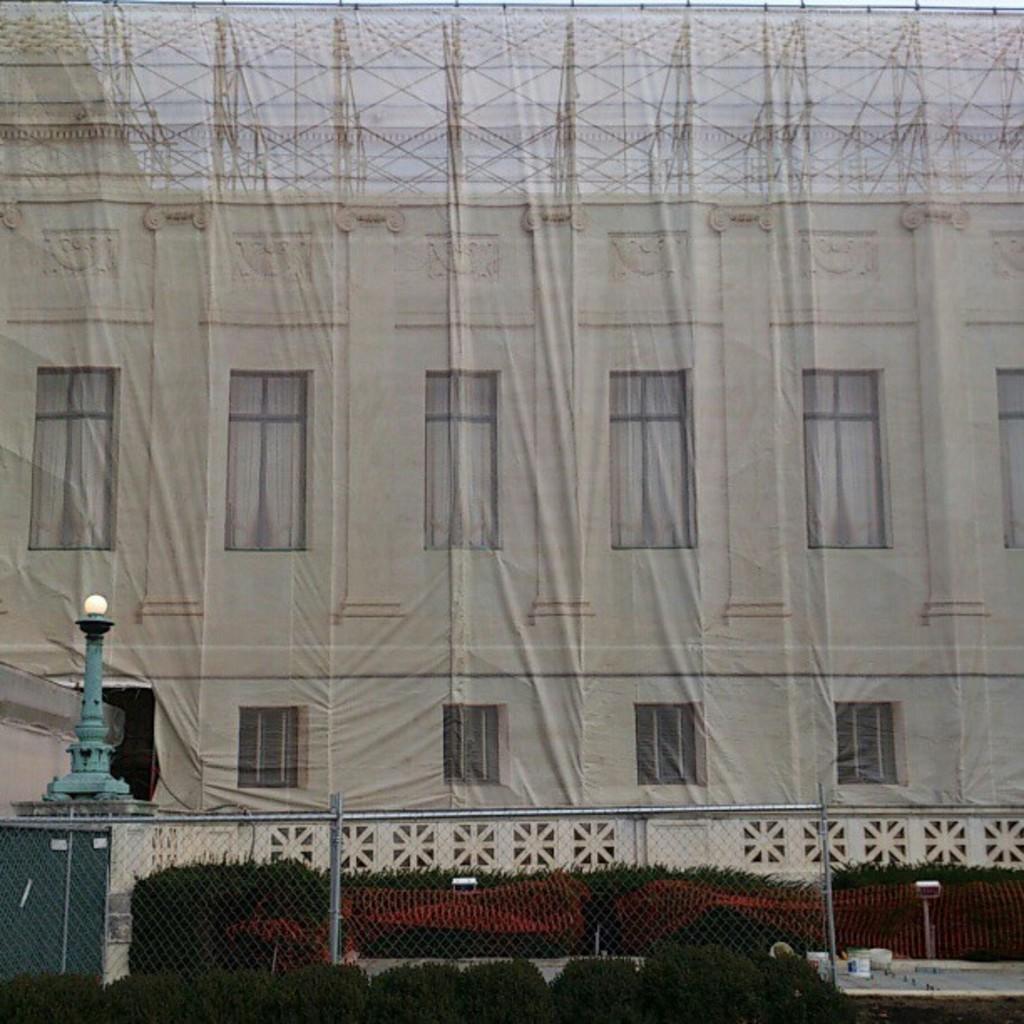Describe this image in one or two sentences. In this image we can see a building. In front of the building fencing and plants are there. Left side of the image one blue color pole is there. 